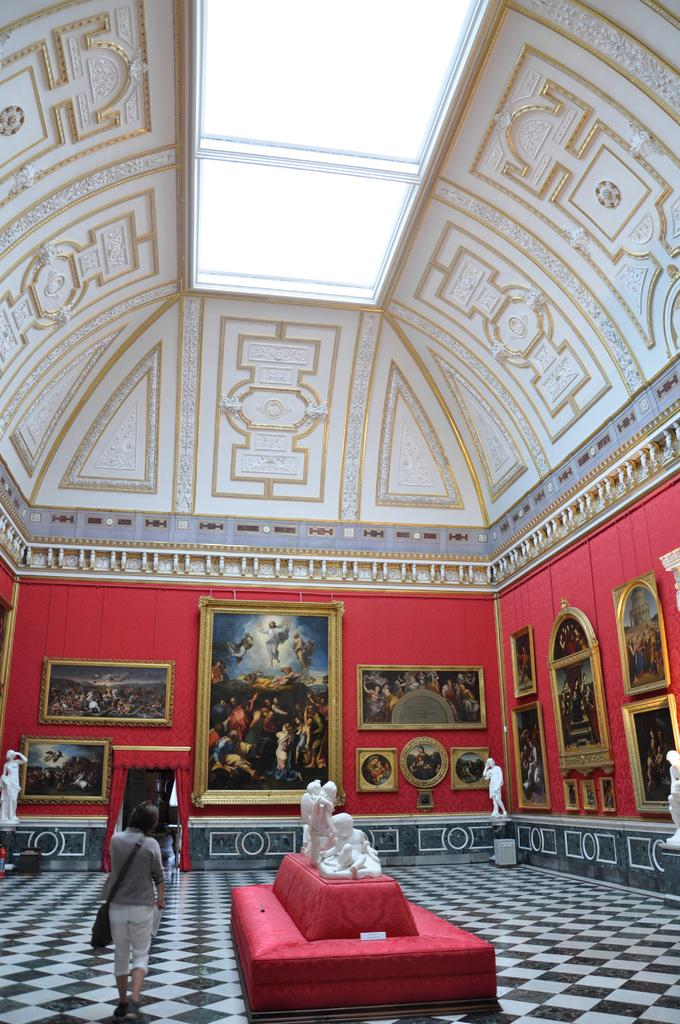What is placed on the red sofa in the image? There is a sculpture on a red color sofa. What is the person in the image doing? A person wearing a bag is walking. What can be seen on the walls in the image? There are many paintings on the wall. Are there any other artistic objects in the image? Yes, statues are present. How many lamps are visible in the image? There is no lamp present in the image. What trick is the person performing while wearing the bag? There is no trick being performed in the image; the person is simply walking while wearing a bag. 